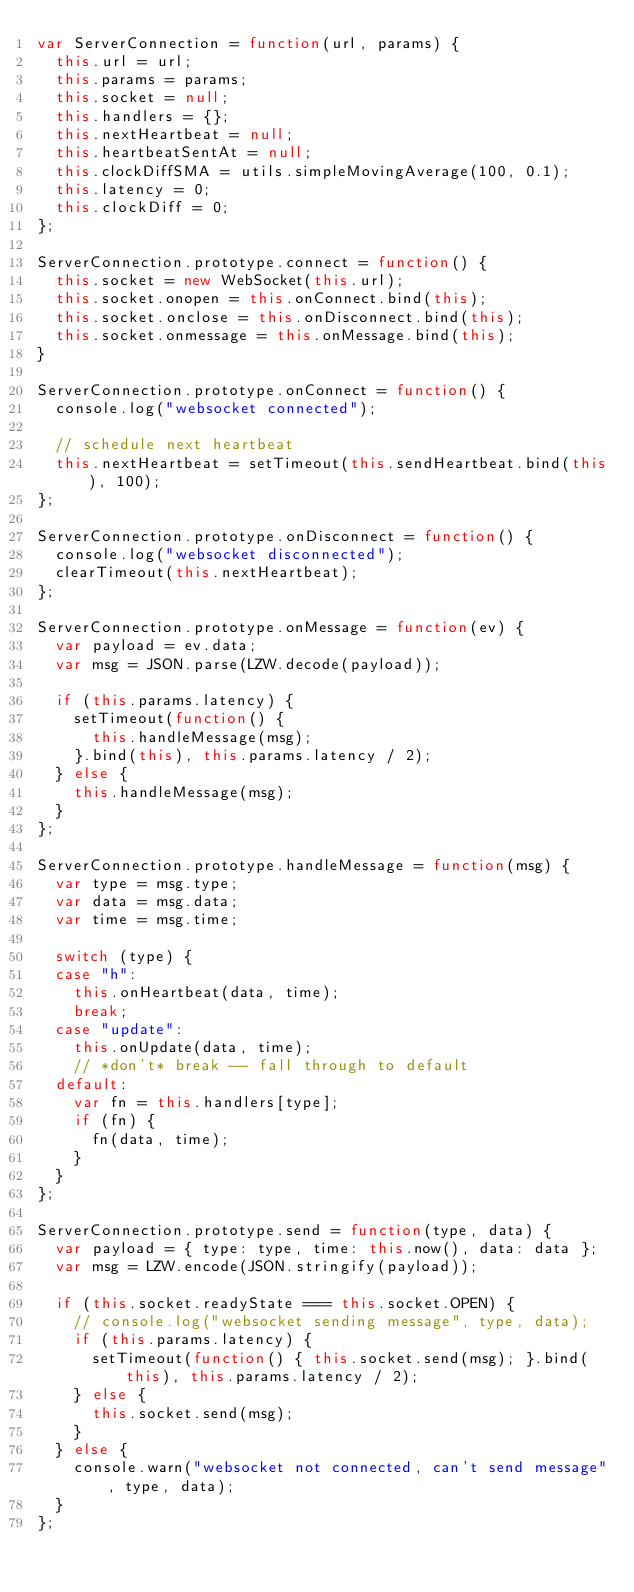<code> <loc_0><loc_0><loc_500><loc_500><_JavaScript_>var ServerConnection = function(url, params) {
  this.url = url;
  this.params = params;
  this.socket = null;
  this.handlers = {};
  this.nextHeartbeat = null;
  this.heartbeatSentAt = null;
  this.clockDiffSMA = utils.simpleMovingAverage(100, 0.1);
  this.latency = 0;
  this.clockDiff = 0;
};

ServerConnection.prototype.connect = function() {
  this.socket = new WebSocket(this.url);
  this.socket.onopen = this.onConnect.bind(this);
  this.socket.onclose = this.onDisconnect.bind(this);
  this.socket.onmessage = this.onMessage.bind(this);
}

ServerConnection.prototype.onConnect = function() {
  console.log("websocket connected");

  // schedule next heartbeat
  this.nextHeartbeat = setTimeout(this.sendHeartbeat.bind(this), 100);
};

ServerConnection.prototype.onDisconnect = function() {
  console.log("websocket disconnected");
  clearTimeout(this.nextHeartbeat);
};

ServerConnection.prototype.onMessage = function(ev) {
  var payload = ev.data;
  var msg = JSON.parse(LZW.decode(payload));

  if (this.params.latency) {
    setTimeout(function() {
      this.handleMessage(msg);
    }.bind(this), this.params.latency / 2);
  } else {
    this.handleMessage(msg);
  }
};

ServerConnection.prototype.handleMessage = function(msg) {
  var type = msg.type;
  var data = msg.data;
  var time = msg.time;

  switch (type) {
  case "h":
    this.onHeartbeat(data, time);
    break;
  case "update":
    this.onUpdate(data, time);
    // *don't* break -- fall through to default
  default:
    var fn = this.handlers[type];
    if (fn) {
      fn(data, time);
    }
  }
};

ServerConnection.prototype.send = function(type, data) {
  var payload = { type: type, time: this.now(), data: data };
  var msg = LZW.encode(JSON.stringify(payload));

  if (this.socket.readyState === this.socket.OPEN) {
    // console.log("websocket sending message", type, data);
    if (this.params.latency) {
      setTimeout(function() { this.socket.send(msg); }.bind(this), this.params.latency / 2);
    } else {
      this.socket.send(msg);
    }
  } else {
    console.warn("websocket not connected, can't send message", type, data);
  }
};
</code> 